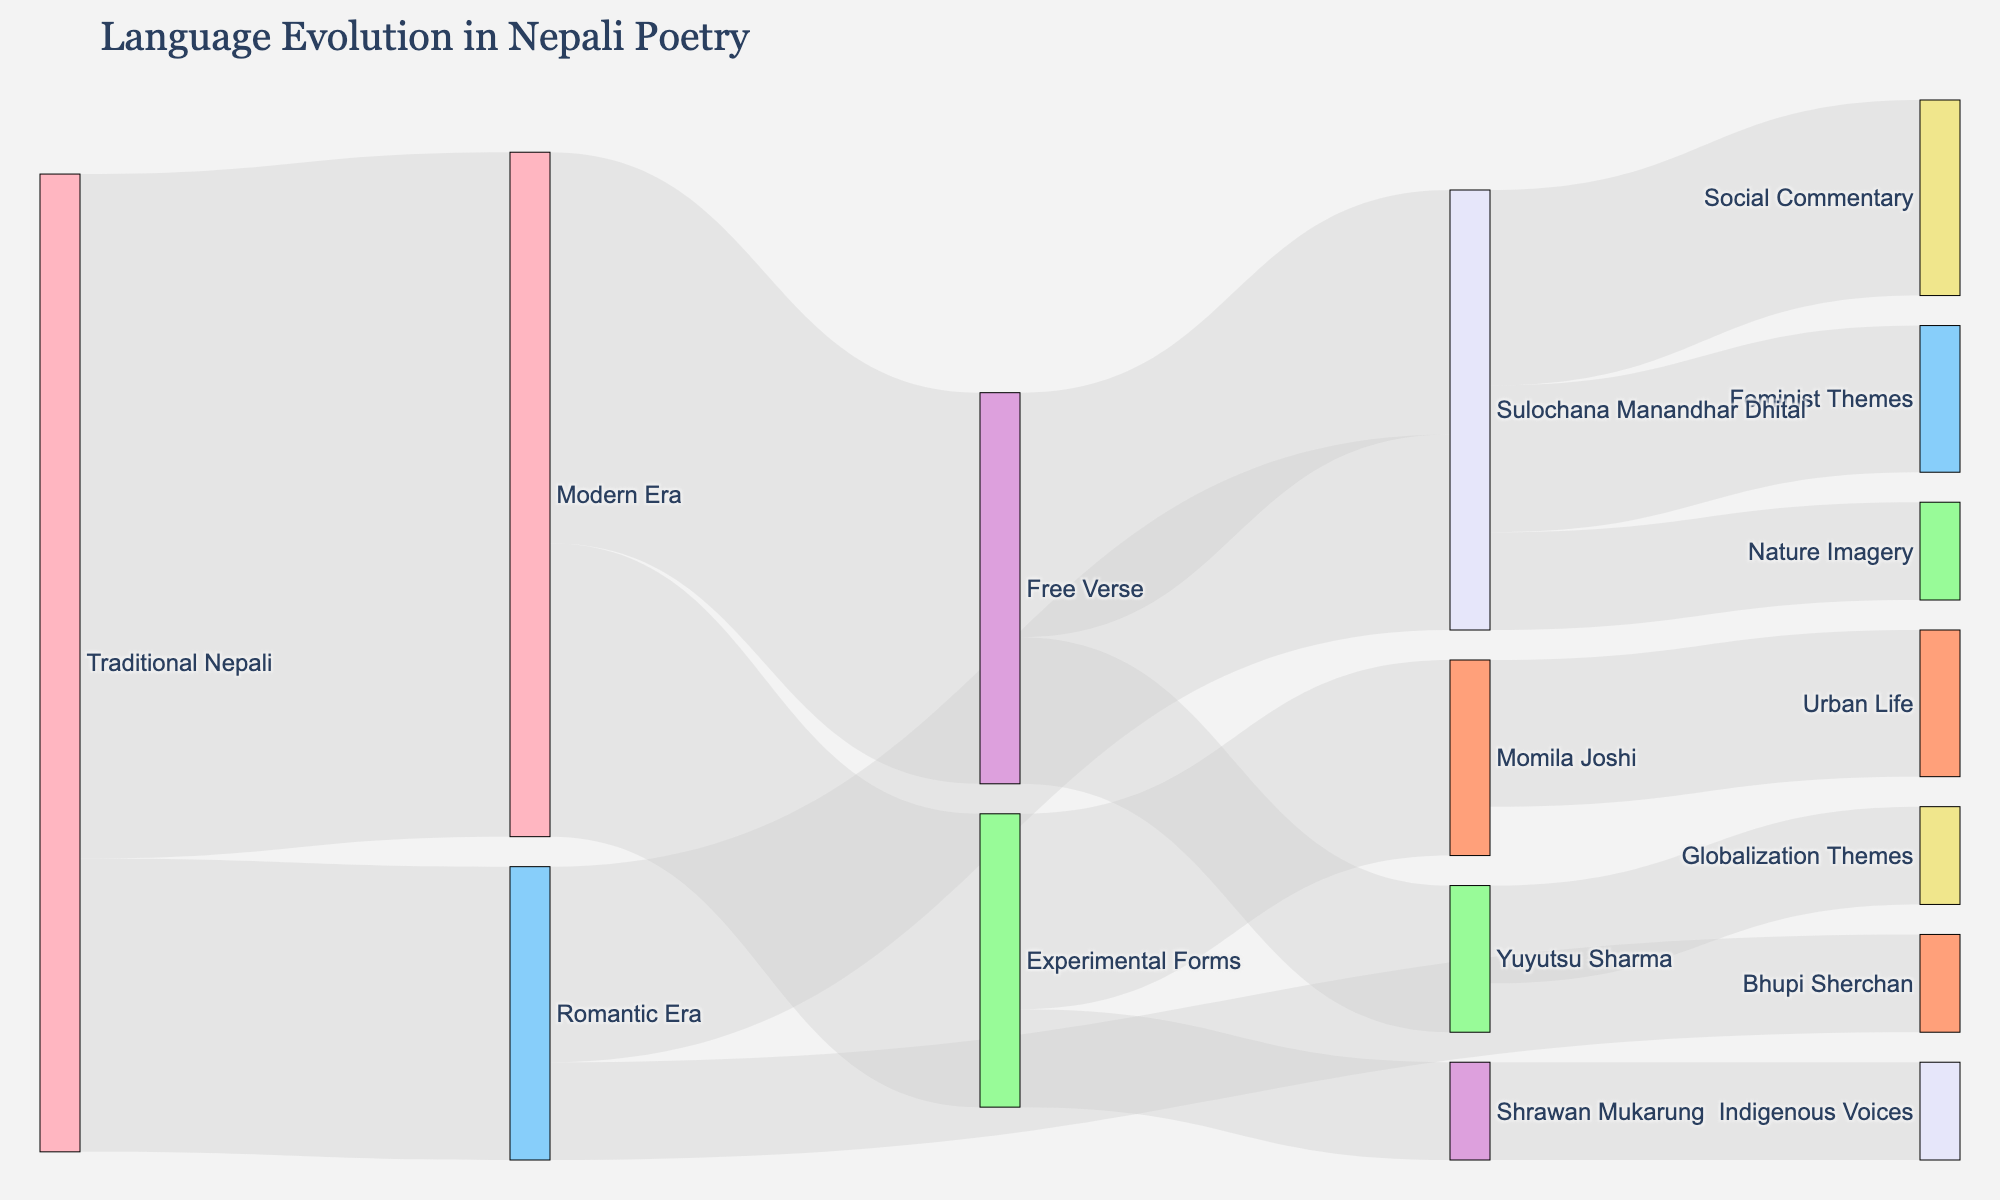How many traditional Nepali influences are transitioned into the Romantic Era? The transition from Traditional Nepali to the Romantic Era is represented by a single link. By checking the value of this link, we can determine that 30 traditional Nepali influences transition to the Romantic Era.
Answer: 30 Which poet is more influenced by Free Verse, Sulochana Manandhar Dhital or Yuyutsu Sharma? By comparing the flow values from Free Verse to Sulochana Manandhar Dhital and Yuyutsu Sharma, we find that the value of the link to Sulochana Manandhar Dhital is 25, while the value of the link to Yuyutsu Sharma is 15. Therefore, Sulochana Manandhar Dhital is more influenced by Free Verse.
Answer: Sulochana Manandhar Dhital What is the total influence value derived from Modern Era to subsequent poetic forms? The Modern Era flows into two subsequent forms: Free Verse with a value of 40 and Experimental Forms with a value of 30. The total influence value is the sum of these two values: 40 + 30 = 70.
Answer: 70 Which theme has the highest influence value from Sulochana Manandhar Dhital's poetry? By examining the links stemming from Sulochana Manandhar Dhital, we observe three themes: Feminist Themes with a value of 15, Nature Imagery with a value of 10, and Social Commentary with a value of 20. Social Commentary has the highest influence value.
Answer: Social Commentary How does the influence of Traditional Nepali poetry split between the Romantic and Modern Eras, and which is greater? Traditional Nepali poetry splits into the Romantic Era with a value of 30 and the Modern Era with a value of 70. By comparing these values, we see that the influence on the Modern Era is greater.
Answer: Modern Era What is the combined influence value of Momila Joshi and Shrawan Mukarung in the Experimental Forms category? The values for Momila Joshi and Shrawan Mukarung in the Experimental Forms category are 20 and 10, respectively. Summing these values gives us 20 + 10 = 30.
Answer: 30 How much influence value does Sulochana Manandhar Dhital derive from the Romantic Era and Free Verse combined? Sulochana Manandhar Dhital's influence values from the Romantic Era and Free Verse are 20 and 25, respectively. Adding these values results in 20 + 25 = 45.
Answer: 45 Comparing the influences from the Romantic Era, does Bhupi Sherchan have more or less influence than Sulochana Manandhar Dhital? From the Romantic Era, Bhupi Sherchan has an influence value of 10, while Sulochana Manandhar Dhital has an influence value of 20. Thus, Bhupi Sherchan has less influence.
Answer: Less 